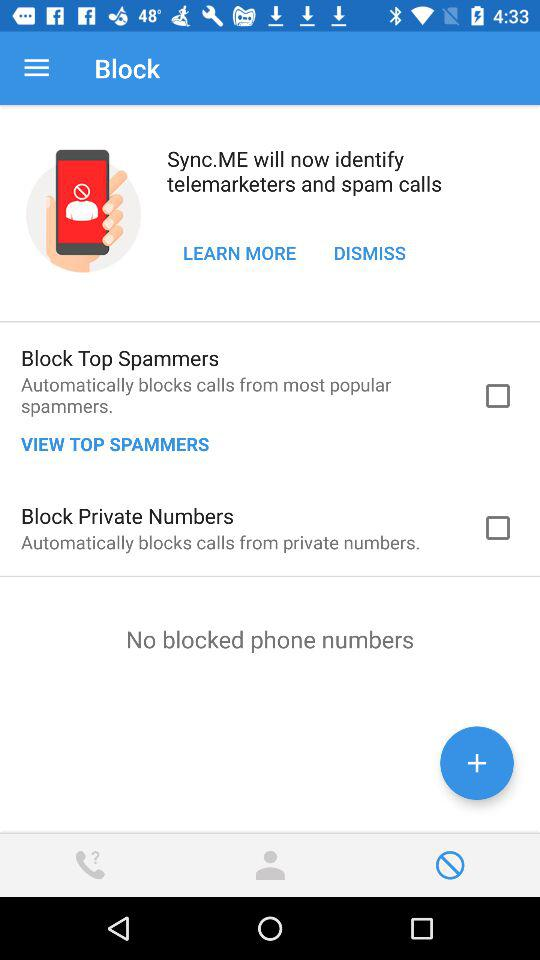What is the status of "Block Private Numbers"? The status is "off". 